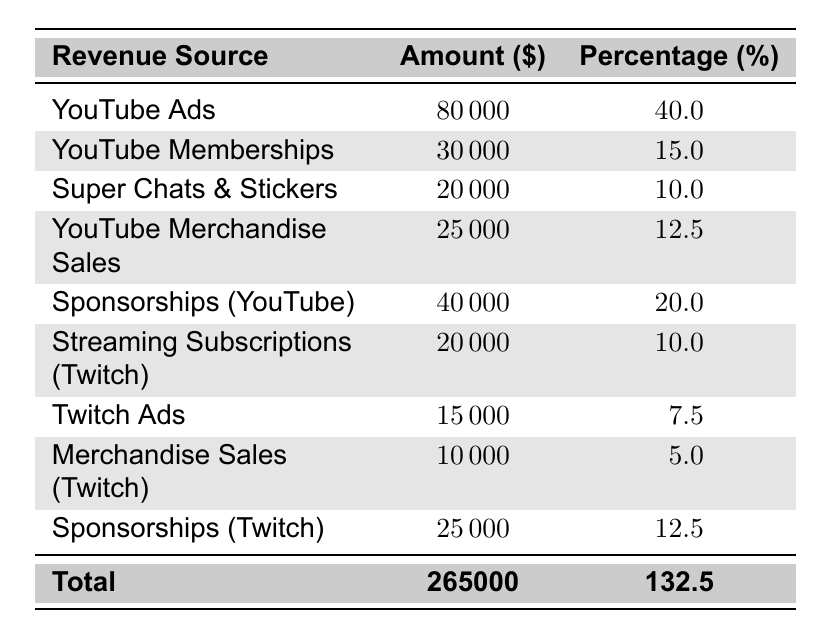What is the total revenue from YouTube Ads? The table shows the revenue for YouTube Ads is listed as 80,000 dollars.
Answer: 80,000 What percentage of the total revenue comes from Sponsorships (YouTube)? The revenue from Sponsorships (YouTube) is 40,000 dollars and the total revenue is 265,000 dollars. To find the percentage from Sponsorships (YouTube), we calculate (40,000 / 265,000) * 100, which equals approximately 15.1%.
Answer: 15.1% What is the total revenue generated from Twitch platform sources? The revenue from the Twitch platform sources consists of Streaming Subscriptions (20,000), Twitch Ads (15,000), Merchandise Sales (10,000), and Sponsorships (25,000). Adding these together: 20,000 + 15,000 + 10,000 + 25,000 = 70,000 dollars.
Answer: 70,000 Which category has the highest revenue? Scanning down the revenue amounts in the table, YouTube Ads has the highest revenue of 80,000 dollars.
Answer: YouTube Ads What is the difference in revenue between YouTube Merchandise Sales and Merchandise Sales (Twitch)? YouTube Merchandise Sales revenue is 25,000 dollars, and Merchandise Sales (Twitch) is 10,000 dollars. The difference is 25,000 - 10,000 = 15,000 dollars.
Answer: 15,000 What total percentage of revenue comes from YouTube sources? The percentages from YouTube sources are: YouTube Ads (40%), Memberships (15%), Super Chats & Stickers (10%), Merchandise Sales (12.5%), and Sponsorships (20%). Adding these percentages gives: 40 + 15 + 10 + 12.5 + 20 = 97.5%.
Answer: 97.5% Is the revenue from Twitch Ads less than that from Super Chats & Stickers? The revenue from Twitch Ads is 15,000 dollars, and from Super Chats & Stickers is 20,000 dollars. Thus, 15,000 is less than 20,000, making this statement true.
Answer: Yes What is the average revenue from each YouTube source? The total revenue from YouTube sources is 80,000 + 30,000 + 20,000 + 25,000 + 40,000 = 195,000 dollars. There are 5 YouTube sources, so the average is 195,000 / 5 = 39,000 dollars.
Answer: 39,000 If a viewer supports both YouTube and Twitch entirely through Super Chats & Stickers and Streaming Subscriptions, what is their total contribution? Super Chats & Stickers revenue is 20,000 dollars and streaming subscriptions revenue is 20,000 dollars. Adding these together gives 20,000 + 20,000 = 40,000 dollars.
Answer: 40,000 What percentage does Twitch contribute to the total revenue? The total revenue from Twitch is 70,000 dollars out of 265,000 total revenue. The percentage from Twitch is (70,000 / 265,000) * 100, which equals approximately 26.4%.
Answer: 26.4% 